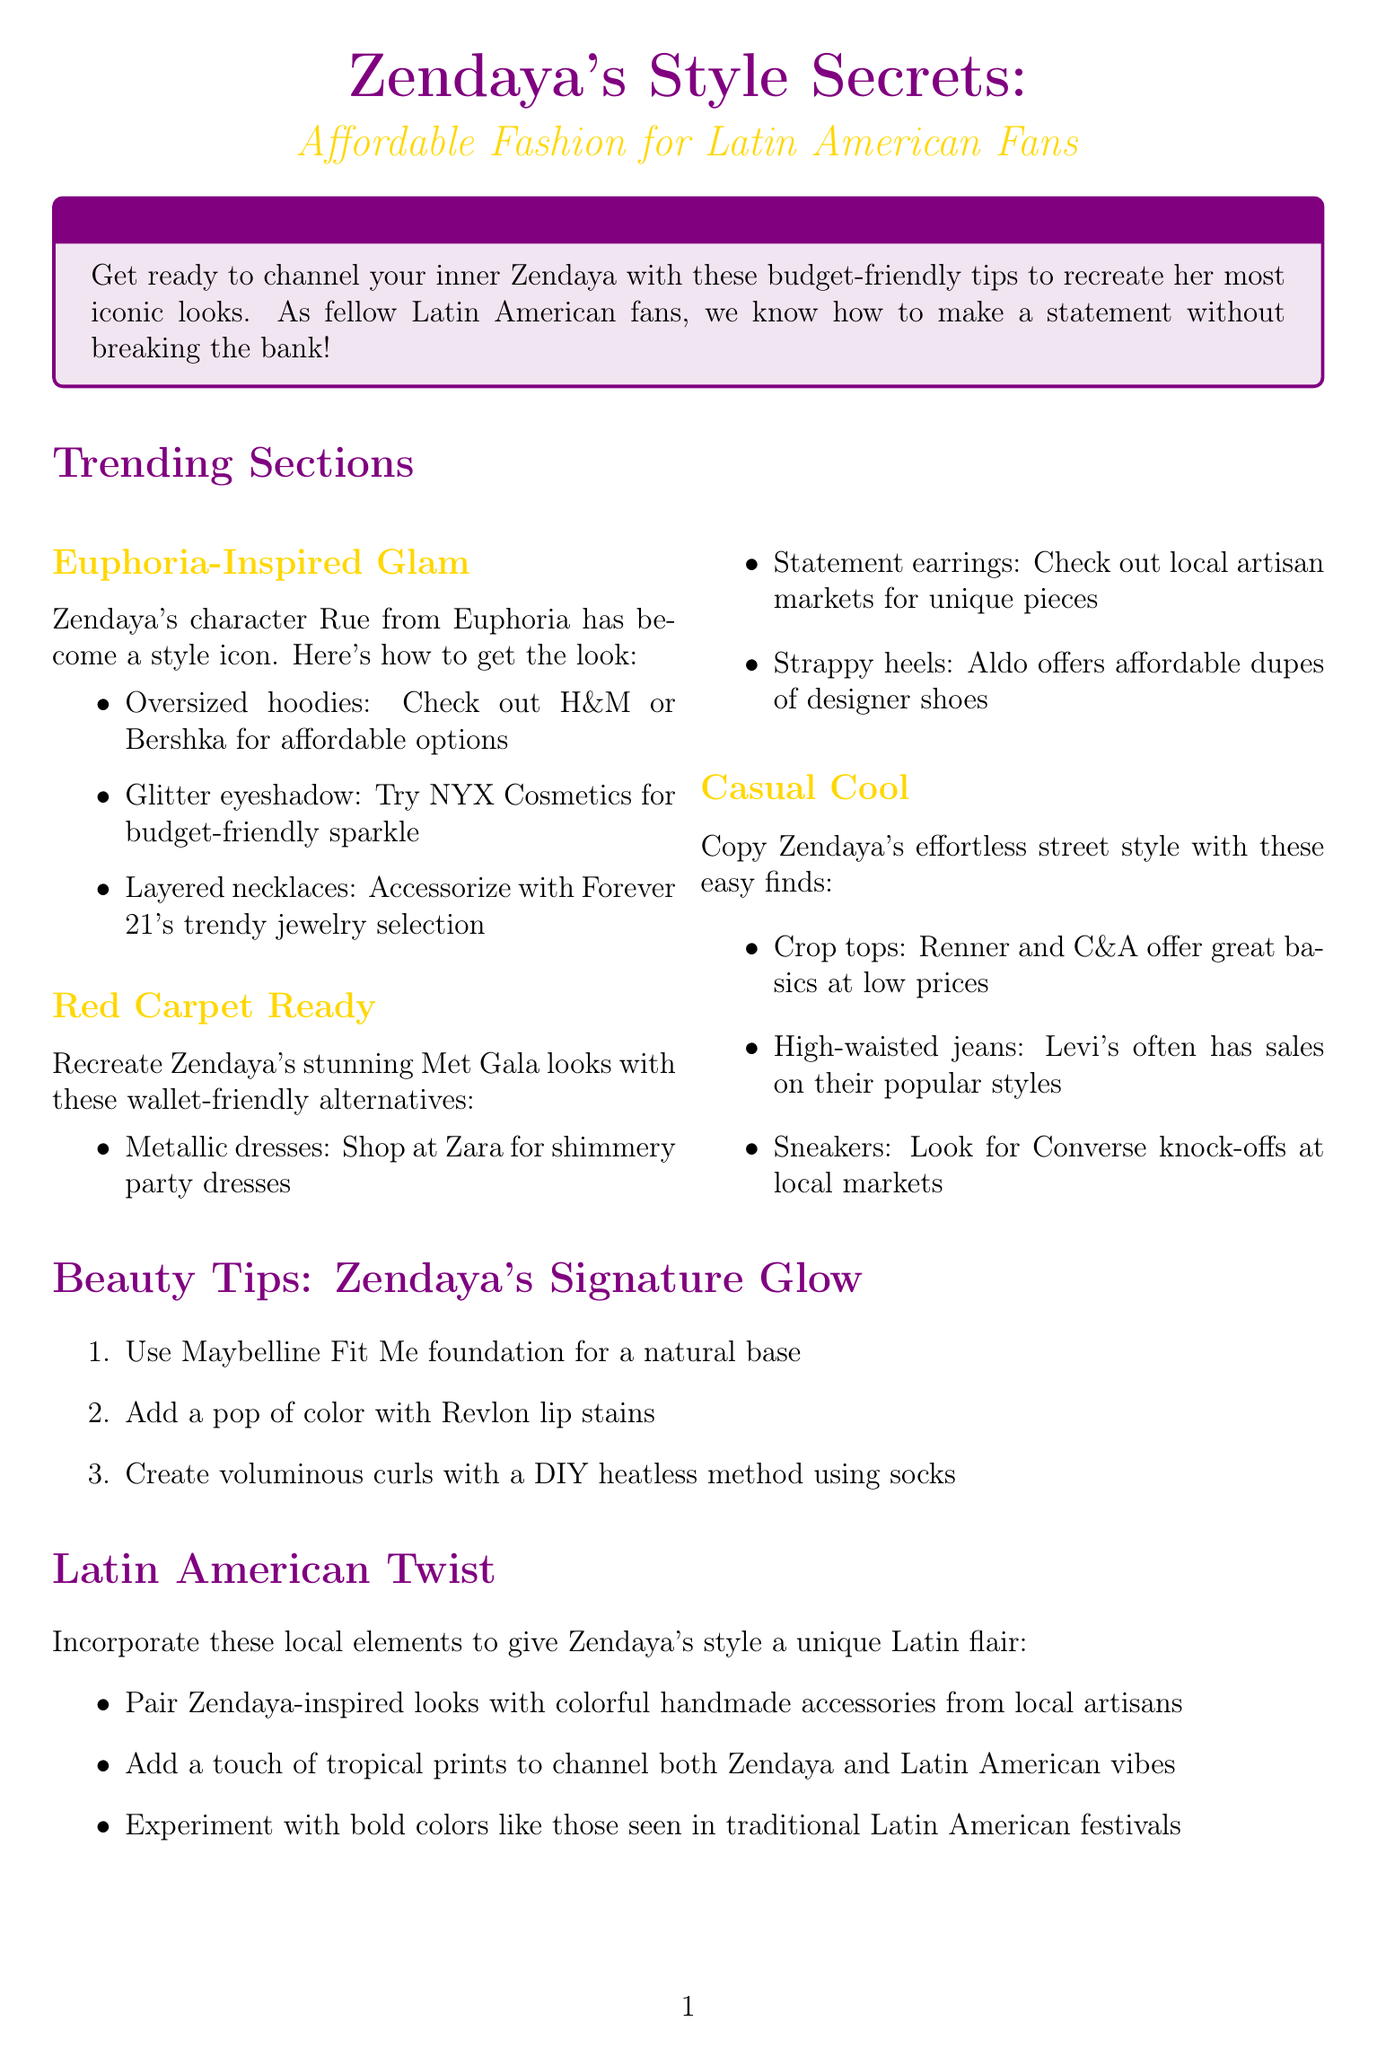What is the title of the newsletter? The title of the newsletter is mentioned at the top of the document, introducing the theme of the content.
Answer: Zendaya's Style Secrets: Affordable Fashion for Latin American Fans How many beauty tips are provided? The document lists a series of tips under the Beauty Tips section.
Answer: 3 Which item is suggested for Euphoria-Inspired Glam? One specific item under Euphoria-Inspired Glam is highlighted in the list of fashion tips.
Answer: Oversized hoodies What local element is suggested to give Zendaya's style a unique Latin flair? The document describes local adaptations to Zendaya’s style, highlighting specific accessories or prints.
Answer: Colorful handmade accessories What is the hashtag to share Zendaya-inspired looks? A section encourages fans to use a specific hashtag when sharing their style on social media.
Answer: #ZendayaLatinStyle What brand is suggested for strappy heels? The document lists affordable alternatives and mentions a specific brand for those heels.
Answer: Aldo Which cosmetic brand is recommended for glitter eyeshadow? Glitter eyeshadow is recommended from a specific budget-friendly cosmetic brand in the document.
Answer: NYX Cosmetics What kind of jeans are suggested for casual street style? A specific type of jeans is mentioned in the lifestyle section that captures Zendaya’s casual look.
Answer: High-waisted jeans 